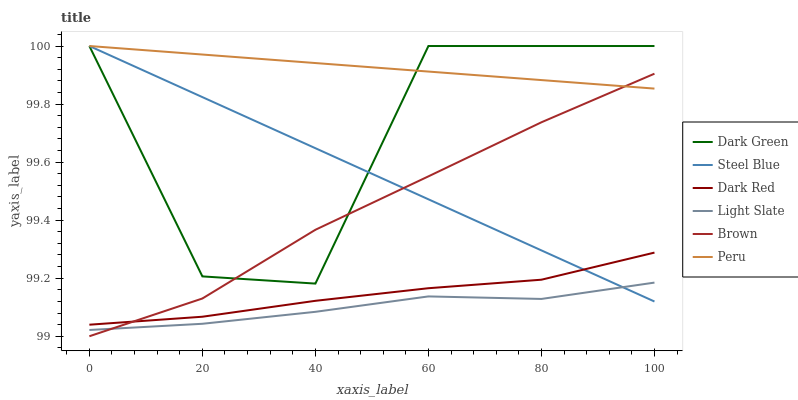Does Dark Red have the minimum area under the curve?
Answer yes or no. No. Does Dark Red have the maximum area under the curve?
Answer yes or no. No. Is Light Slate the smoothest?
Answer yes or no. No. Is Light Slate the roughest?
Answer yes or no. No. Does Light Slate have the lowest value?
Answer yes or no. No. Does Dark Red have the highest value?
Answer yes or no. No. Is Light Slate less than Dark Green?
Answer yes or no. Yes. Is Dark Red greater than Light Slate?
Answer yes or no. Yes. Does Light Slate intersect Dark Green?
Answer yes or no. No. 